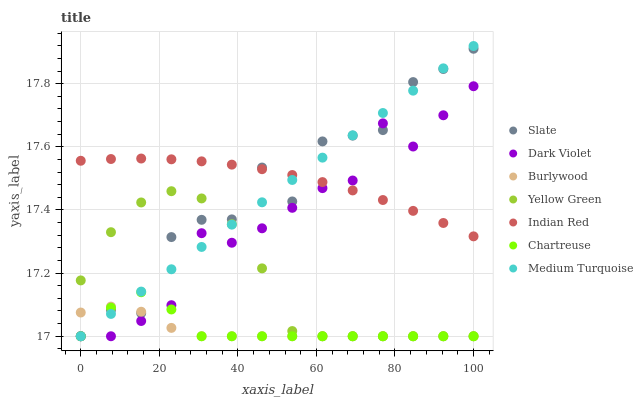Does Burlywood have the minimum area under the curve?
Answer yes or no. Yes. Does Indian Red have the maximum area under the curve?
Answer yes or no. Yes. Does Yellow Green have the minimum area under the curve?
Answer yes or no. No. Does Yellow Green have the maximum area under the curve?
Answer yes or no. No. Is Medium Turquoise the smoothest?
Answer yes or no. Yes. Is Slate the roughest?
Answer yes or no. Yes. Is Yellow Green the smoothest?
Answer yes or no. No. Is Yellow Green the roughest?
Answer yes or no. No. Does Medium Turquoise have the lowest value?
Answer yes or no. Yes. Does Indian Red have the lowest value?
Answer yes or no. No. Does Medium Turquoise have the highest value?
Answer yes or no. Yes. Does Yellow Green have the highest value?
Answer yes or no. No. Is Burlywood less than Indian Red?
Answer yes or no. Yes. Is Indian Red greater than Burlywood?
Answer yes or no. Yes. Does Medium Turquoise intersect Slate?
Answer yes or no. Yes. Is Medium Turquoise less than Slate?
Answer yes or no. No. Is Medium Turquoise greater than Slate?
Answer yes or no. No. Does Burlywood intersect Indian Red?
Answer yes or no. No. 